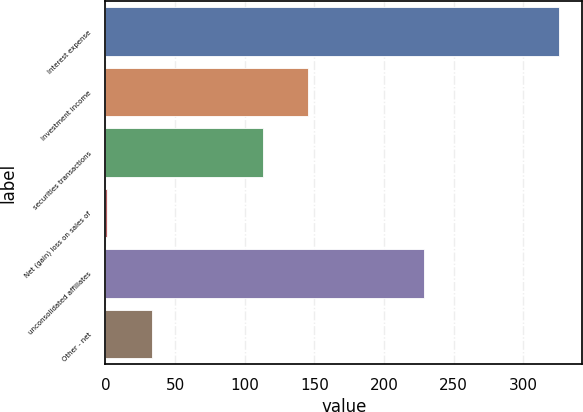<chart> <loc_0><loc_0><loc_500><loc_500><bar_chart><fcel>Interest expense<fcel>Investment income<fcel>securities transactions<fcel>Net (gain) loss on sales of<fcel>unconsolidated affiliates<fcel>Other - net<nl><fcel>326<fcel>145.5<fcel>113<fcel>1<fcel>229<fcel>33.5<nl></chart> 